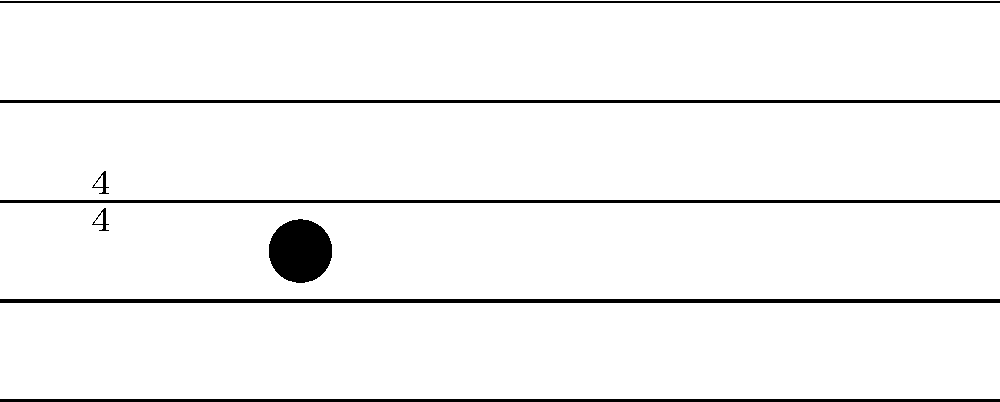In the given traditional drum rhythm notation, which two note shapes are congruent? To determine which note shapes are congruent in this traditional drum rhythm notation, we need to follow these steps:

1. Observe the staff: The image shows a standard 5-line staff with a 4/4 time signature.

2. Identify the notes: There are four quarter notes in the measure.

3. Analyze the note placement:
   - The first note is on the bottom space of the staff.
   - The second note is on the second space from the bottom.
   - The third note is on the bottom space of the staff.
   - The fourth note is on the second space from the bottom.

4. Compare the note shapes:
   - All four notes have the same basic shape: a filled circular notehead with a stem extending upwards.
   - The first and third notes are identical in both shape and position.
   - The second and fourth notes are identical in both shape and position.

5. Apply the definition of congruence: In geometry, two shapes are considered congruent if they have the same size and shape, regardless of their position or orientation.

6. Conclusion: Since all four notes have the same size and shape, they are all congruent to each other. However, the question asks for two note shapes, so we can choose any pair of notes as our answer.
Answer: Any two notes 